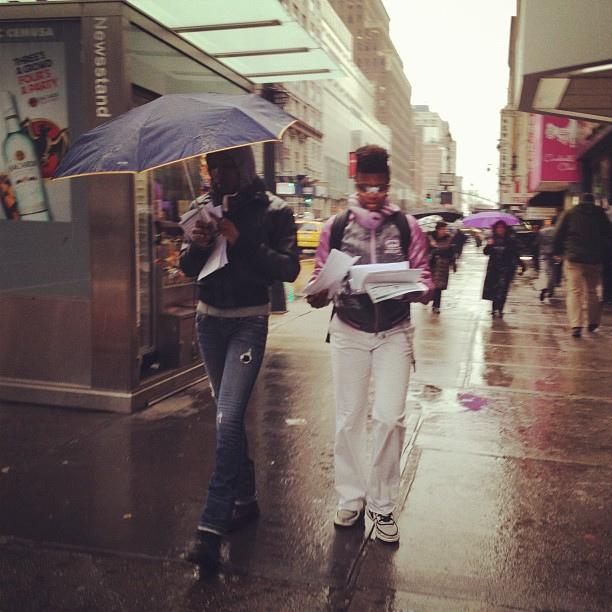Is it raining?
Write a very short answer. Yes. What does the person have in their hands?
Short answer required. Papers. Which hand has the umbrella at the bottom?
Concise answer only. Right. Is the photo taken in a forest?
Give a very brief answer. No. Is the woman by herself?
Concise answer only. No. Are they standing near a crosswalk?
Short answer required. No. What traditional outfit is this woman wearing?
Answer briefly. Jeans. What color is the left umbrella?
Short answer required. Blue. What type of shoes is the woman wearing?
Quick response, please. Tennis shoes. What kind of sign is the boy holding?
Give a very brief answer. Paper. Are all these people wearing pants?
Give a very brief answer. Yes. How many strollers are there?
Keep it brief. 0. 